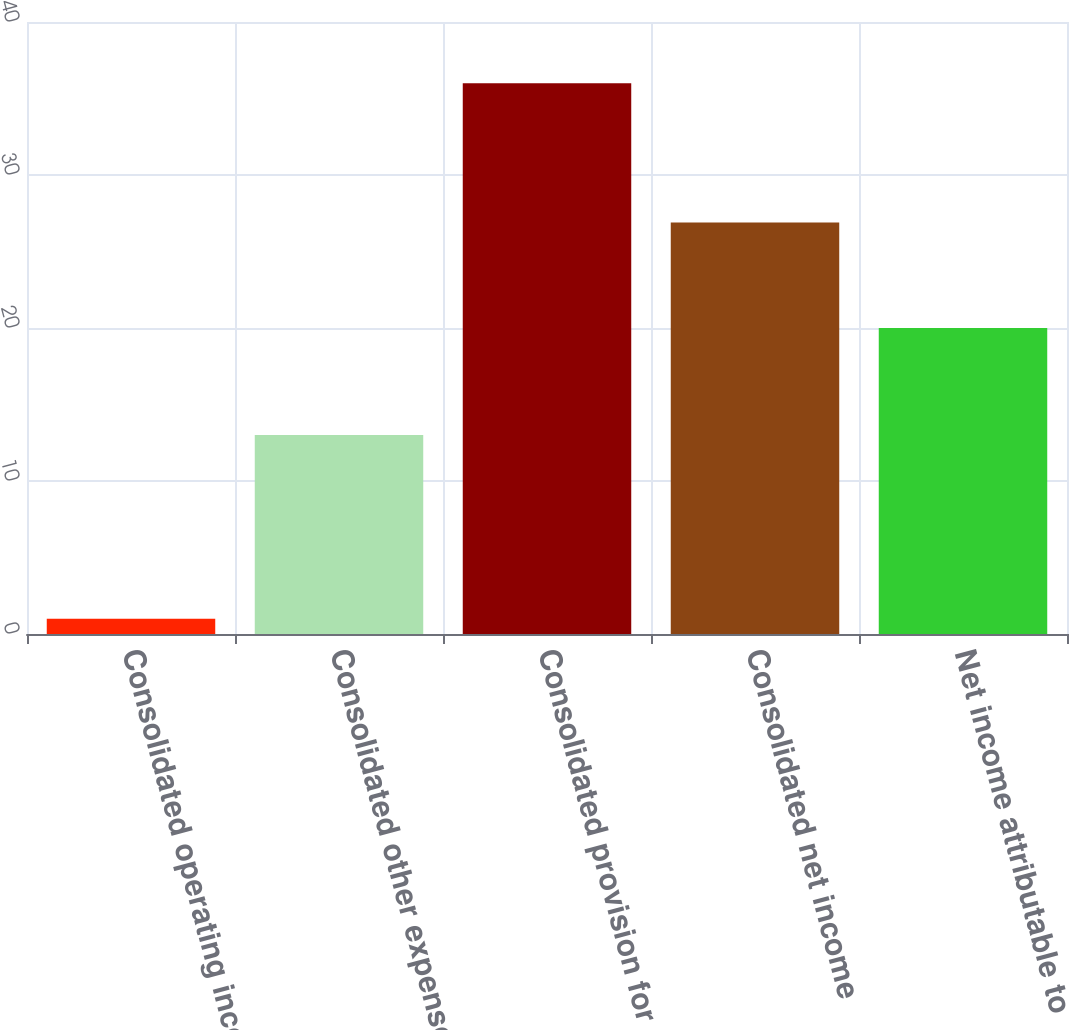<chart> <loc_0><loc_0><loc_500><loc_500><bar_chart><fcel>Consolidated operating income<fcel>Consolidated other expense net<fcel>Consolidated provision for<fcel>Consolidated net income<fcel>Net income attributable to<nl><fcel>1<fcel>13<fcel>36<fcel>26.9<fcel>20<nl></chart> 